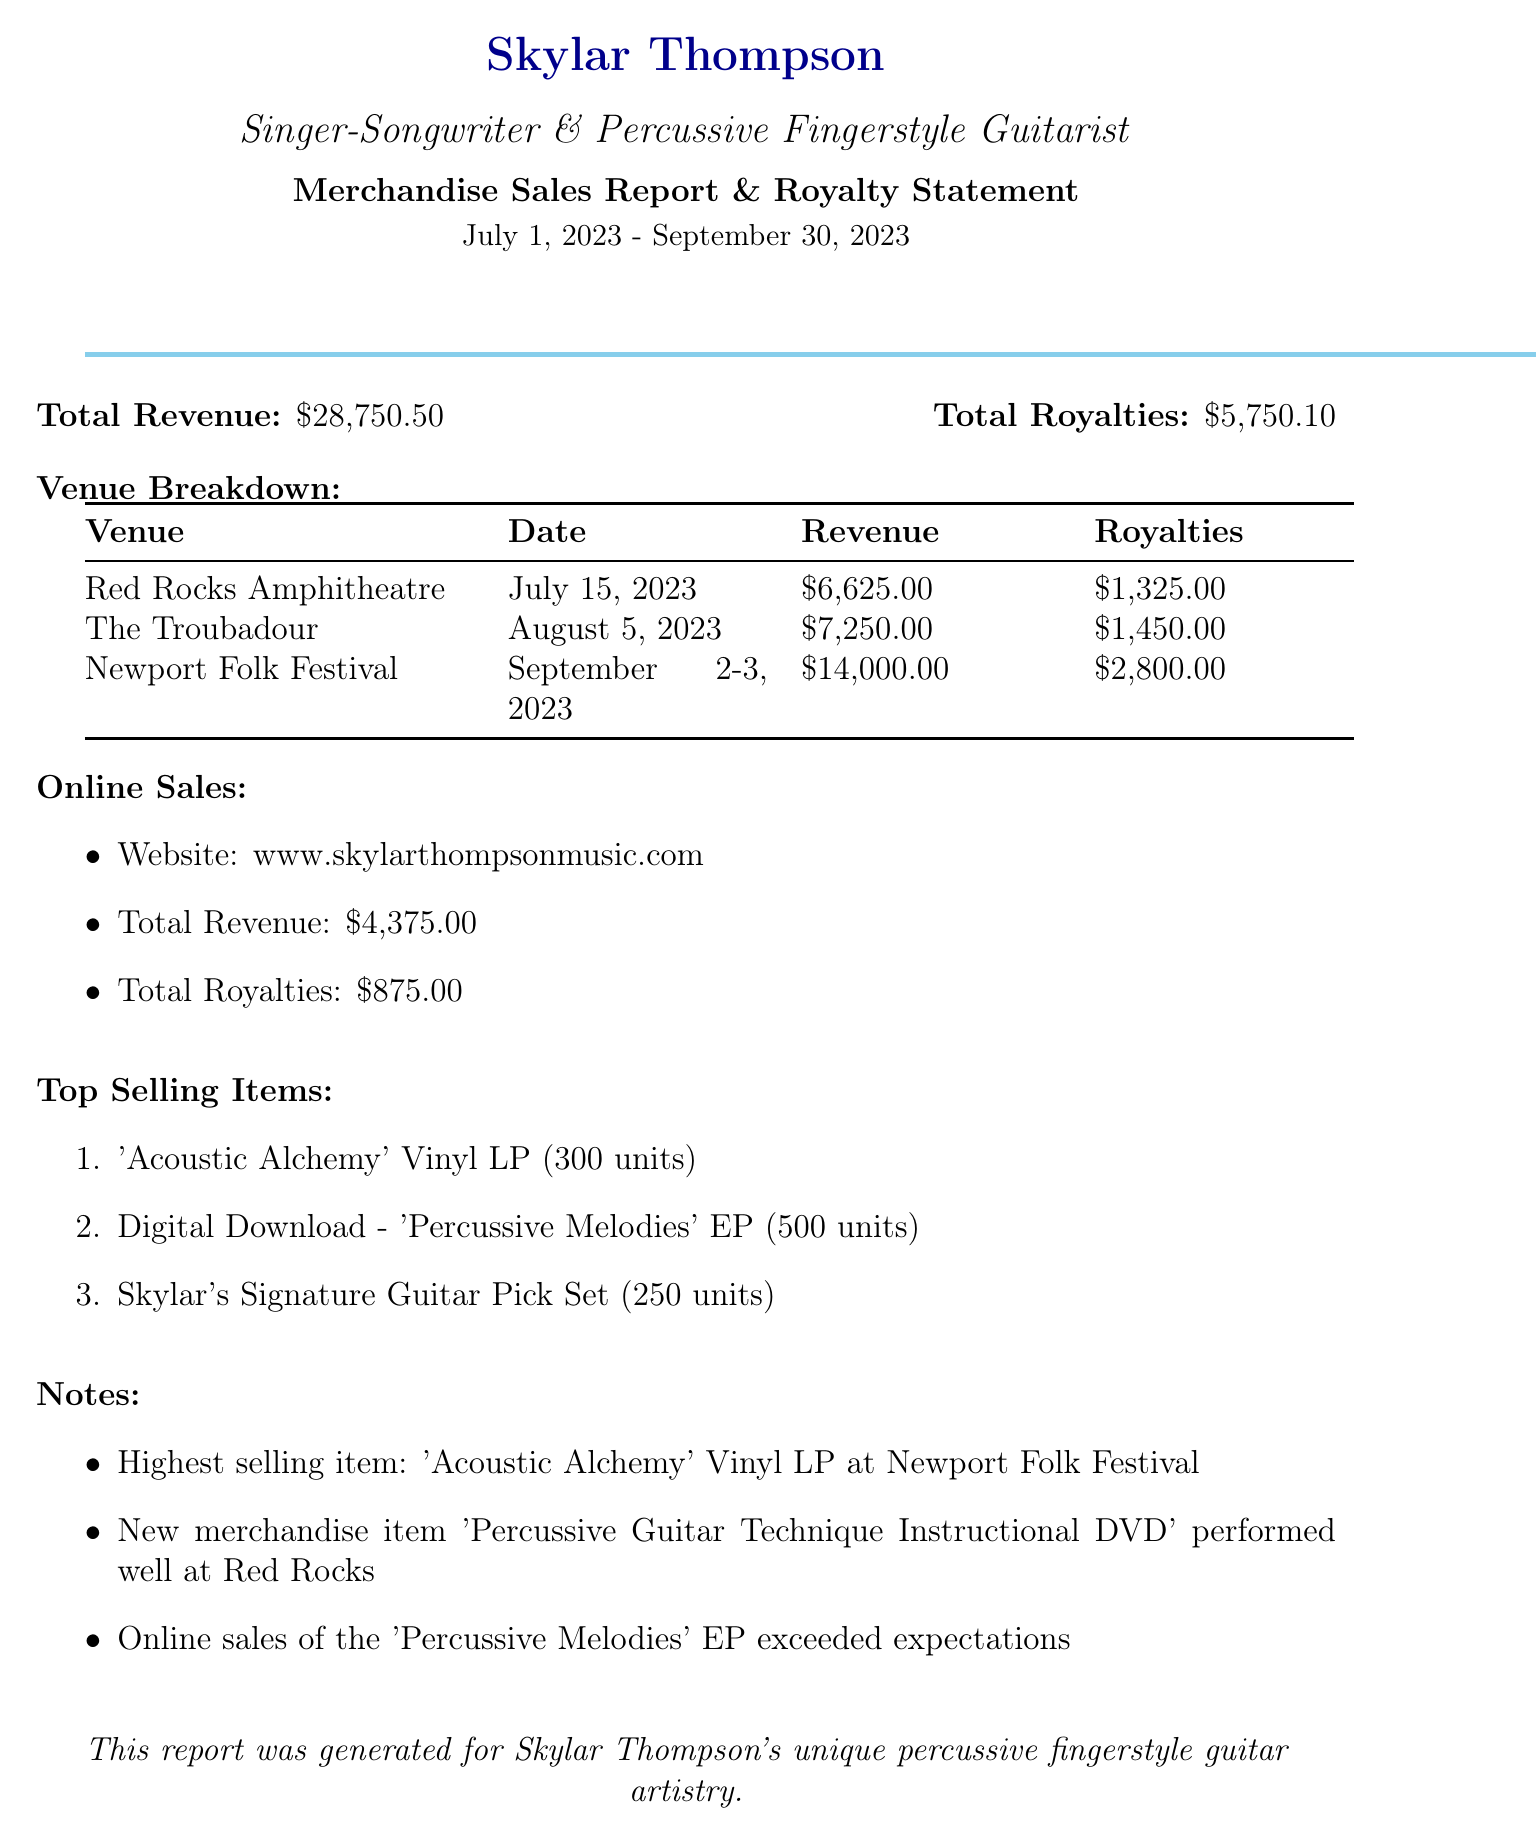What is the total revenue? The total revenue is provided at the top of the document, summing up all revenue sources from merchandise and online sales.
Answer: $28,750.50 What is the total royalties earned? The total royalties are stated alongside the total revenue, representing the earnings from merchandise sales.
Answer: $5,750.10 Which venue generated the highest revenue? The venue breakdown shows the revenue for each venue, highlighting Newport Folk Festival as the highest.
Answer: Newport Folk Festival How many units of the 'Acoustic Alchemy' Vinyl LP were sold? The sales report lists the item sales, with 'Acoustic Alchemy' Vinyl LP indicating 300 units sold.
Answer: 300 What is the date of the performance at The Troubadour? The specific date for The Troubadour performance is mentioned in the venue breakdown section.
Answer: August 5, 2023 What was the revenue from online sales? The online sales section details the total revenue earned specifically from merchandise sold online.
Answer: $4,375.00 Which item had the highest royalty amount? By analyzing the royalty amounts from each item sold, the 'Acoustic Alchemy' Vinyl LP had the highest royalty contribution.
Answer: 'Acoustic Alchemy' Vinyl LP What was notable about the online sales of 'Percussive Melodies' EP? The notes section indicates that online sales exceeded expectations, signifying positive performance.
Answer: Exceeded expectations What is the total revenue from merchandise sold at Red Rocks Amphitheatre? The total revenue from Red Rocks is directly listed under its corresponding venue in the breakdown.
Answer: $6,625.00 